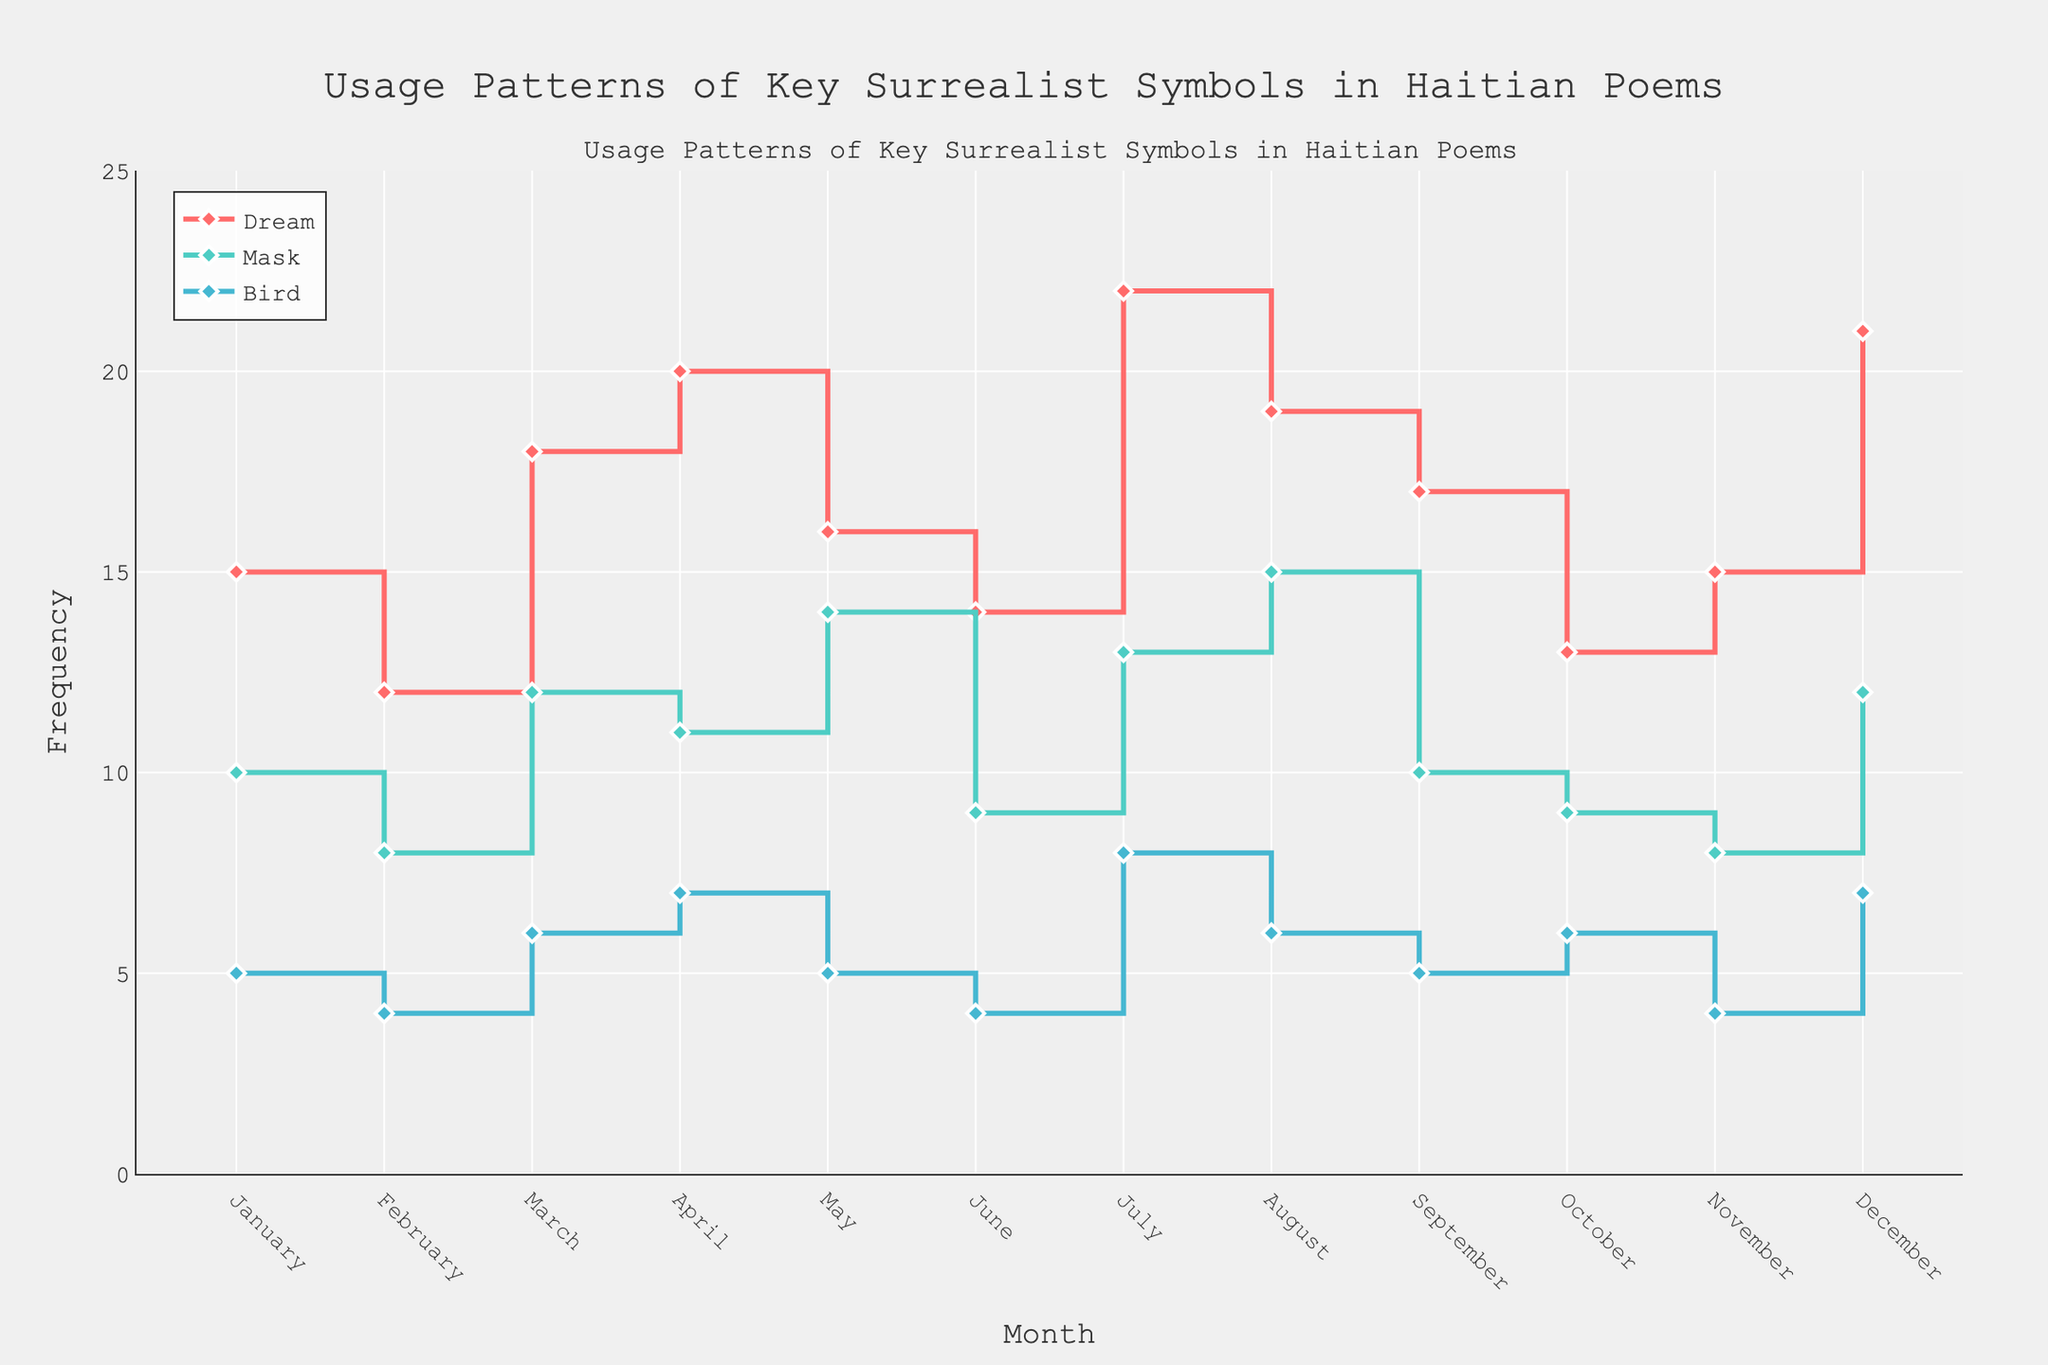What is the title of the figure? The title is prominently displayed at the top of the figure.
Answer: Usage Patterns of Key Surrealist Symbols in Haitian Poems What is the highest frequency recorded for the symbol “Dream”? By visual inspection of the plot for the symbol “Dream,” the peak frequency value can be identified. The highest point is reached in July.
Answer: 22 In which month does the “Bird” symbol have the lowest frequency, and what is the frequency? By examining the "Bird" symbol steps on the plot, we can see the frequency drops to its lowest in February and June.
Answer: 4 What is the difference in the frequency of the “Mask” symbol between May and November? Locate the frequency values on the plot for "Mask" in both months: May (14) and November (8). Subtract the lower value from the higher value: 14 - 8.
Answer: 6 During which month does the frequency of the "Dream" symbol cross above 20? By following the trend line for the "Dream" symbol, locate the month where the frequency first exceeds 20. It is first crossed in April.
Answer: April Compare the frequency of the "Mask" and "Bird" symbols in December. Which one has a higher frequency and by how much? Find the frequencies for both symbols in December on the plot: "Mask" (12) and "Bird" (7). Subtract the lower value from the higher value: 12 - 7.
Answer: Mask, 5 What is the range of the "Dream" symbol frequencies throughout the year? Identify the highest and lowest frequencies for the "Dream" symbol on the plot: highest (22) and lowest (12). Subtract the lowest frequency from the highest: 22 - 12.
Answer: 10 Which month shows equal frequencies for all three symbols? Locate the points where all plotted lines intersect at the same frequency across the same month. This happens in March with frequencies for all symbols equalling 6.
Answer: March What is the combined frequency for the “Mask” symbol in the first and last months of the year? Sum the frequencies for the "Mask" symbol in January (10) and December (12): 10 + 12.
Answer: 22 